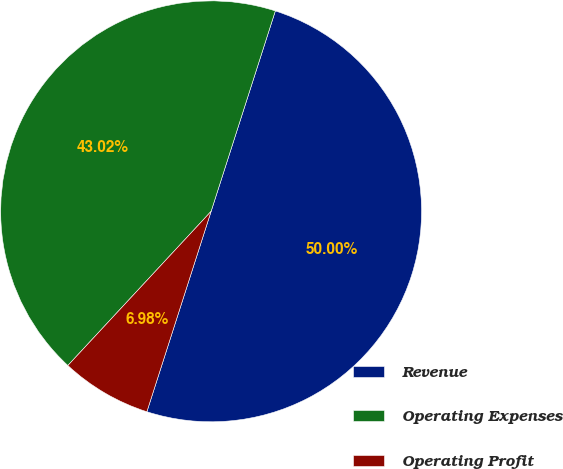Convert chart. <chart><loc_0><loc_0><loc_500><loc_500><pie_chart><fcel>Revenue<fcel>Operating Expenses<fcel>Operating Profit<nl><fcel>50.0%<fcel>43.02%<fcel>6.98%<nl></chart> 